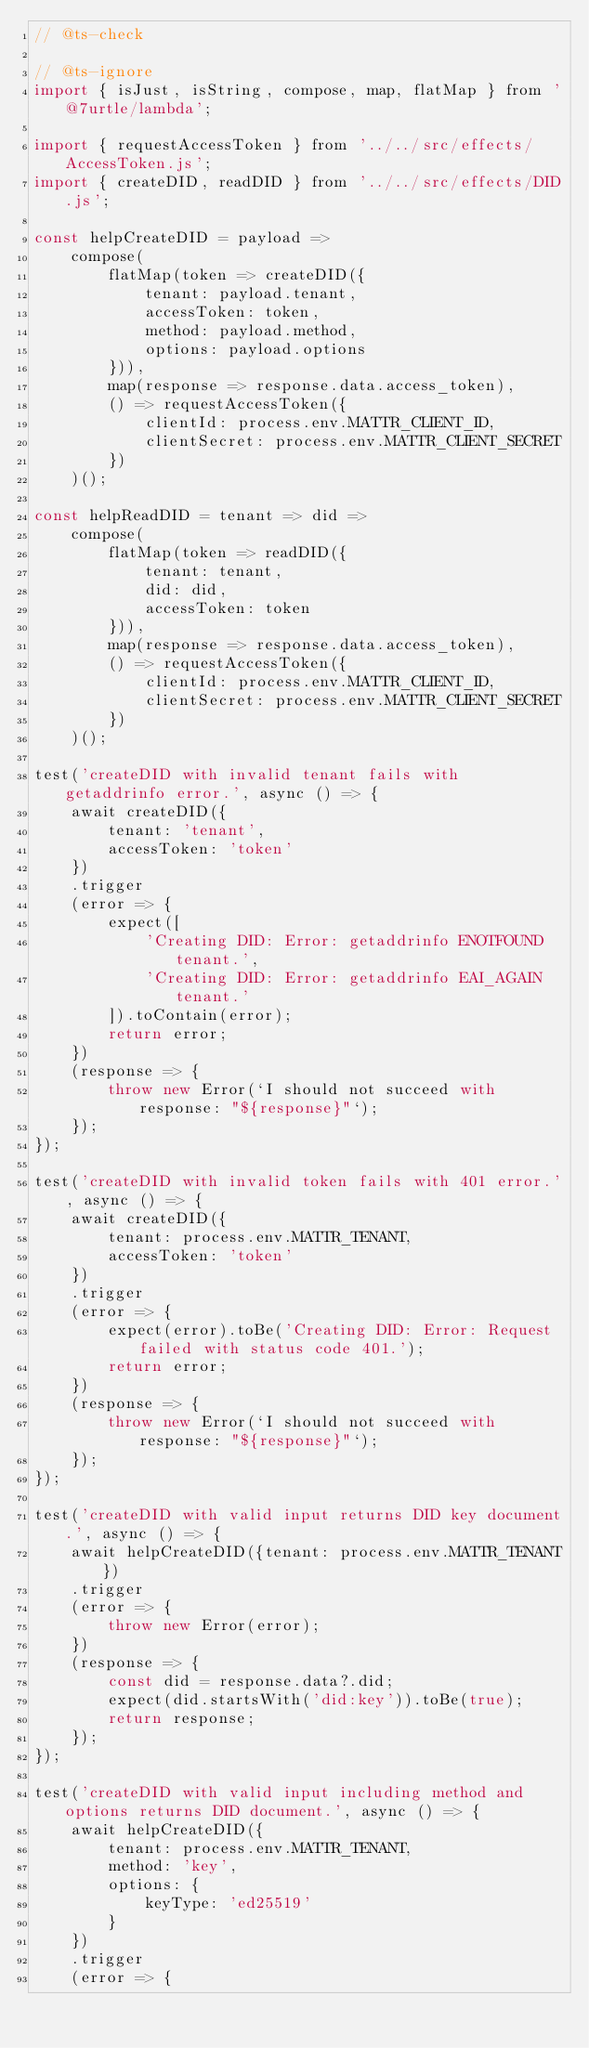Convert code to text. <code><loc_0><loc_0><loc_500><loc_500><_JavaScript_>// @ts-check

// @ts-ignore
import { isJust, isString, compose, map, flatMap } from '@7urtle/lambda';

import { requestAccessToken } from '../../src/effects/AccessToken.js';
import { createDID, readDID } from '../../src/effects/DID.js';

const helpCreateDID = payload =>
    compose(
        flatMap(token => createDID({
            tenant: payload.tenant,
            accessToken: token,
            method: payload.method,
            options: payload.options
        })),
        map(response => response.data.access_token),
        () => requestAccessToken({
            clientId: process.env.MATTR_CLIENT_ID,
            clientSecret: process.env.MATTR_CLIENT_SECRET
        })
    )();

const helpReadDID = tenant => did =>
    compose(
        flatMap(token => readDID({
            tenant: tenant,
            did: did,
            accessToken: token
        })),
        map(response => response.data.access_token),
        () => requestAccessToken({
            clientId: process.env.MATTR_CLIENT_ID,
            clientSecret: process.env.MATTR_CLIENT_SECRET
        })
    )();

test('createDID with invalid tenant fails with getaddrinfo error.', async () => {
    await createDID({
        tenant: 'tenant',
        accessToken: 'token'
    })
    .trigger
    (error => {
        expect([
            'Creating DID: Error: getaddrinfo ENOTFOUND tenant.',
            'Creating DID: Error: getaddrinfo EAI_AGAIN tenant.'
        ]).toContain(error);
        return error;
    })
    (response => {
        throw new Error(`I should not succeed with response: "${response}"`);
    });
});

test('createDID with invalid token fails with 401 error.', async () => {
    await createDID({
        tenant: process.env.MATTR_TENANT,
        accessToken: 'token'
    })
    .trigger
    (error => {
        expect(error).toBe('Creating DID: Error: Request failed with status code 401.');
        return error;
    })
    (response => {
        throw new Error(`I should not succeed with response: "${response}"`);
    });
});

test('createDID with valid input returns DID key document.', async () => {
    await helpCreateDID({tenant: process.env.MATTR_TENANT})
    .trigger
    (error => {
        throw new Error(error);
    })
    (response => {
        const did = response.data?.did;
        expect(did.startsWith('did:key')).toBe(true);
        return response;
    });
});

test('createDID with valid input including method and options returns DID document.', async () => {
    await helpCreateDID({
        tenant: process.env.MATTR_TENANT,
        method: 'key',
        options: {
            keyType: 'ed25519'
        }
    })
    .trigger
    (error => {</code> 